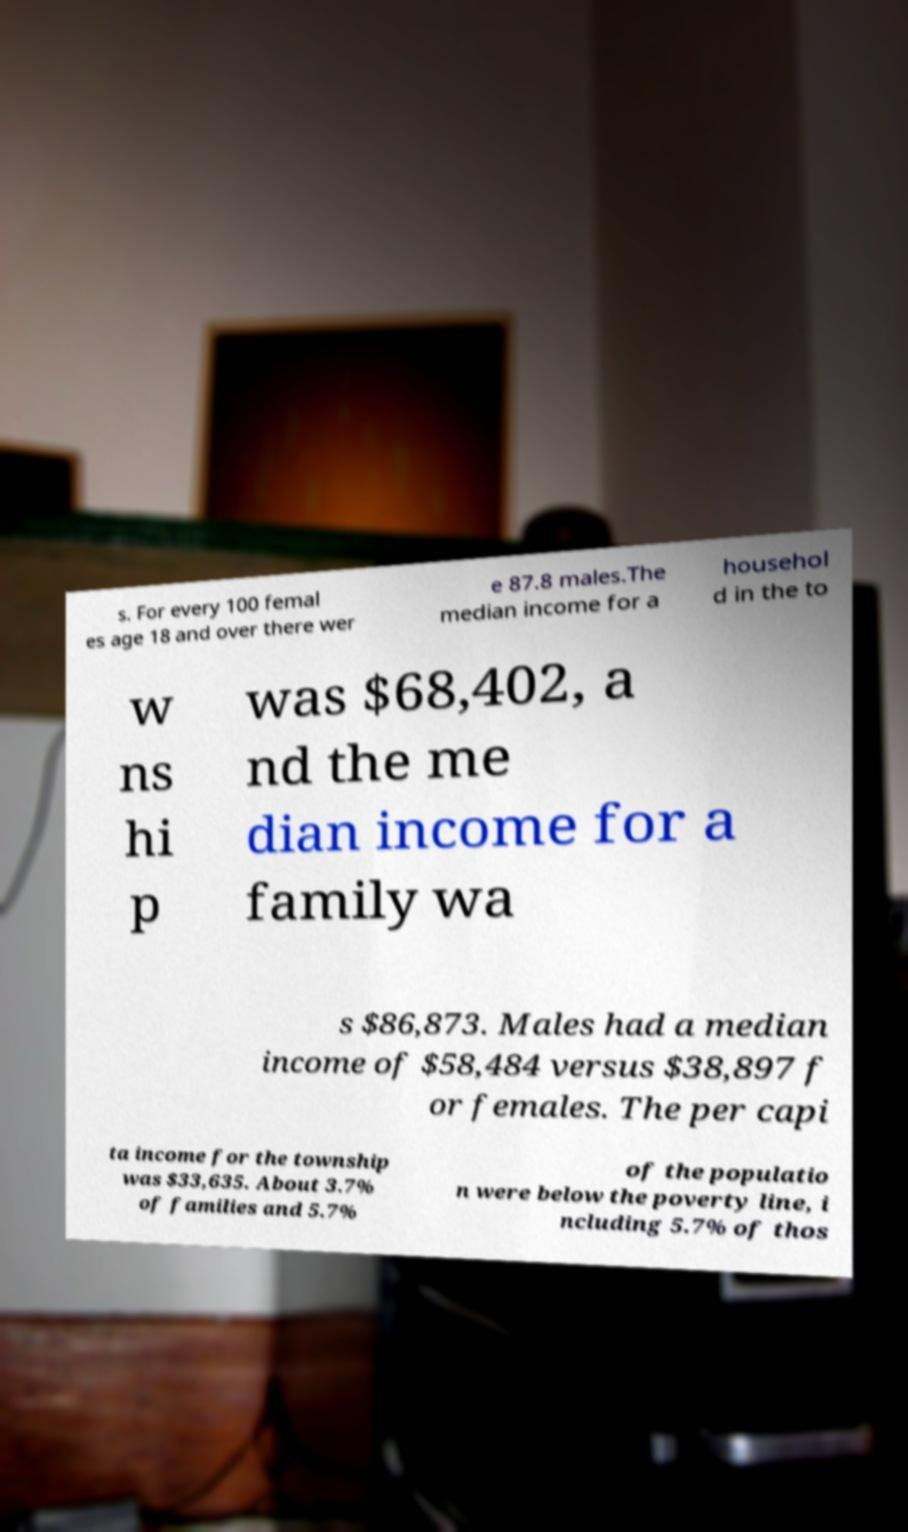What messages or text are displayed in this image? I need them in a readable, typed format. s. For every 100 femal es age 18 and over there wer e 87.8 males.The median income for a househol d in the to w ns hi p was $68,402, a nd the me dian income for a family wa s $86,873. Males had a median income of $58,484 versus $38,897 f or females. The per capi ta income for the township was $33,635. About 3.7% of families and 5.7% of the populatio n were below the poverty line, i ncluding 5.7% of thos 